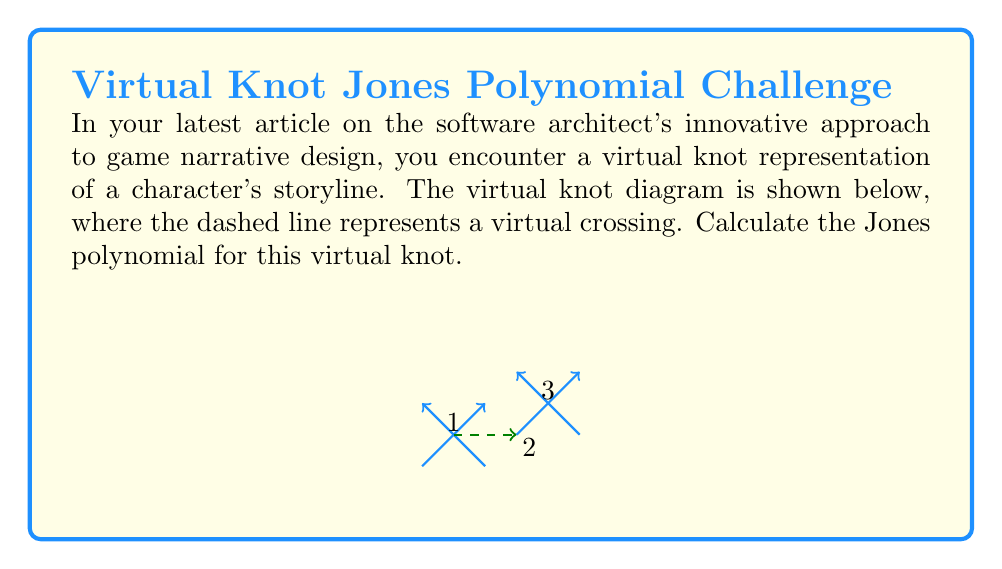Provide a solution to this math problem. To calculate the Jones polynomial for this virtual knot, we'll follow these steps:

1) First, we need to understand that for virtual knots, we ignore the virtual crossings when calculating the writhe. The writhe of this knot is therefore +1 (one positive crossing).

2) We'll use the bracket polynomial $\langle K \rangle$ and then convert it to the Jones polynomial.

3) For the bracket polynomial, we consider both the A-state and B-state at each classical crossing:

   A-state: $\langle \bigcirc \bigcirc \rangle = (-A^2 - A^{-2})$
   B-state: $\langle \bigcirc \rangle = 1$

4) The bracket polynomial is:

   $\langle K \rangle = A \langle \bigcirc \bigcirc \rangle + A^{-1} \langle \bigcirc \rangle$
   $= A(-A^2 - A^{-2}) + A^{-1}$
   $= -A^3 - A^{-1} + A^{-1}$
   $= -A^3$

5) To get the Jones polynomial, we use the formula:

   $V_K(t) = (-A^3)^{-w} \langle K \rangle |_{A = t^{-1/4}}$

   where $w$ is the writhe of the knot.

6) Substituting:

   $V_K(t) = (-A^3)^{-1} (-A^3) |_{A = t^{-1/4}}$
   $= (-1)^{-1} (-1) |_{A = t^{-1/4}}$
   $= 1$

Therefore, the Jones polynomial for this virtual knot is simply 1.
Answer: $V_K(t) = 1$ 